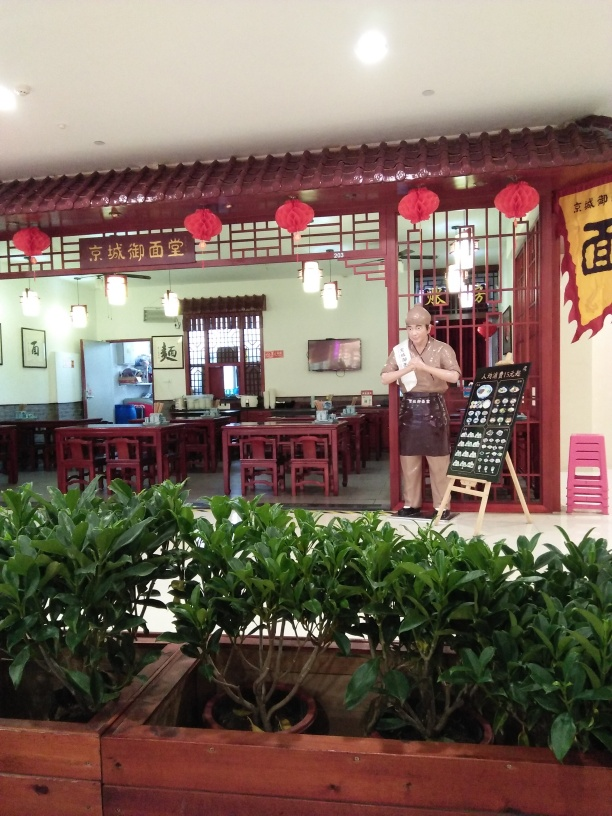Does the image capture the shop effectively? The image provides a clear view of the interior of the shop, showing off the traditional decor and seating arrangement. The presence of the person holding a menu gives a sense of the shop's friendly ambiance and customer service. However, the angle at which the photo was taken limits the view of the items for sale, which are essential for fully capturing the essence of the shop. 